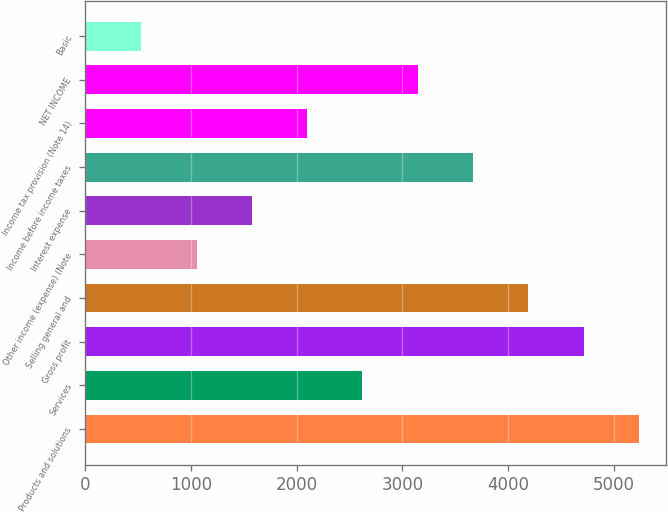Convert chart. <chart><loc_0><loc_0><loc_500><loc_500><bar_chart><fcel>Products and solutions<fcel>Services<fcel>Gross profit<fcel>Selling general and<fcel>Other income (expense) (Note<fcel>Interest expense<fcel>Income before income taxes<fcel>Income tax provision (Note 14)<fcel>NET INCOME<fcel>Basic<nl><fcel>5239.3<fcel>2622.41<fcel>4715.89<fcel>4192.52<fcel>1052.3<fcel>1575.67<fcel>3669.15<fcel>2099.04<fcel>3145.78<fcel>528.93<nl></chart> 